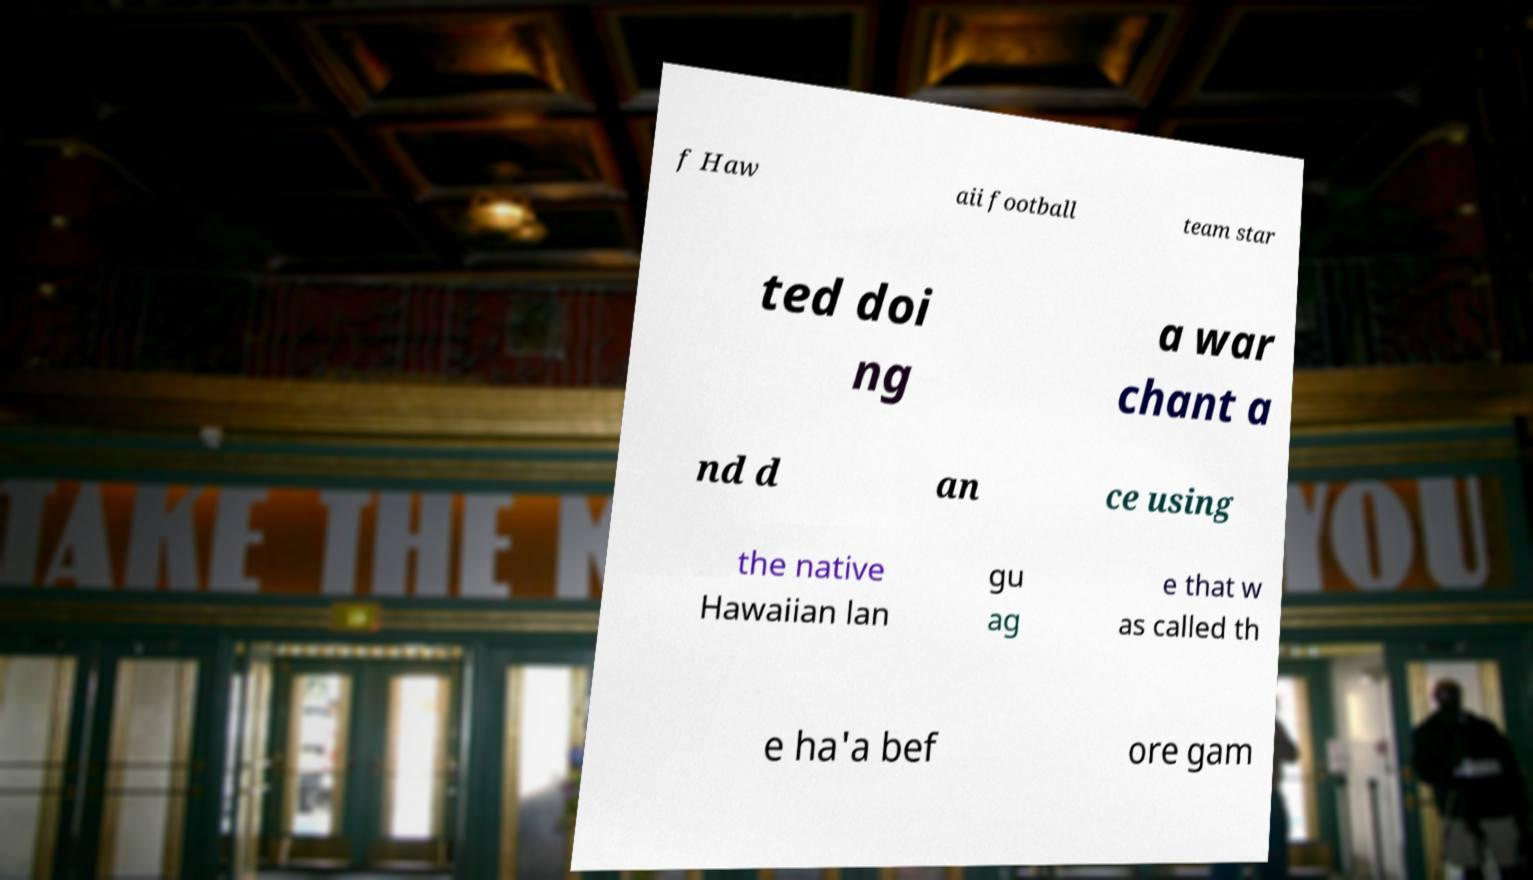Can you read and provide the text displayed in the image?This photo seems to have some interesting text. Can you extract and type it out for me? f Haw aii football team star ted doi ng a war chant a nd d an ce using the native Hawaiian lan gu ag e that w as called th e ha'a bef ore gam 